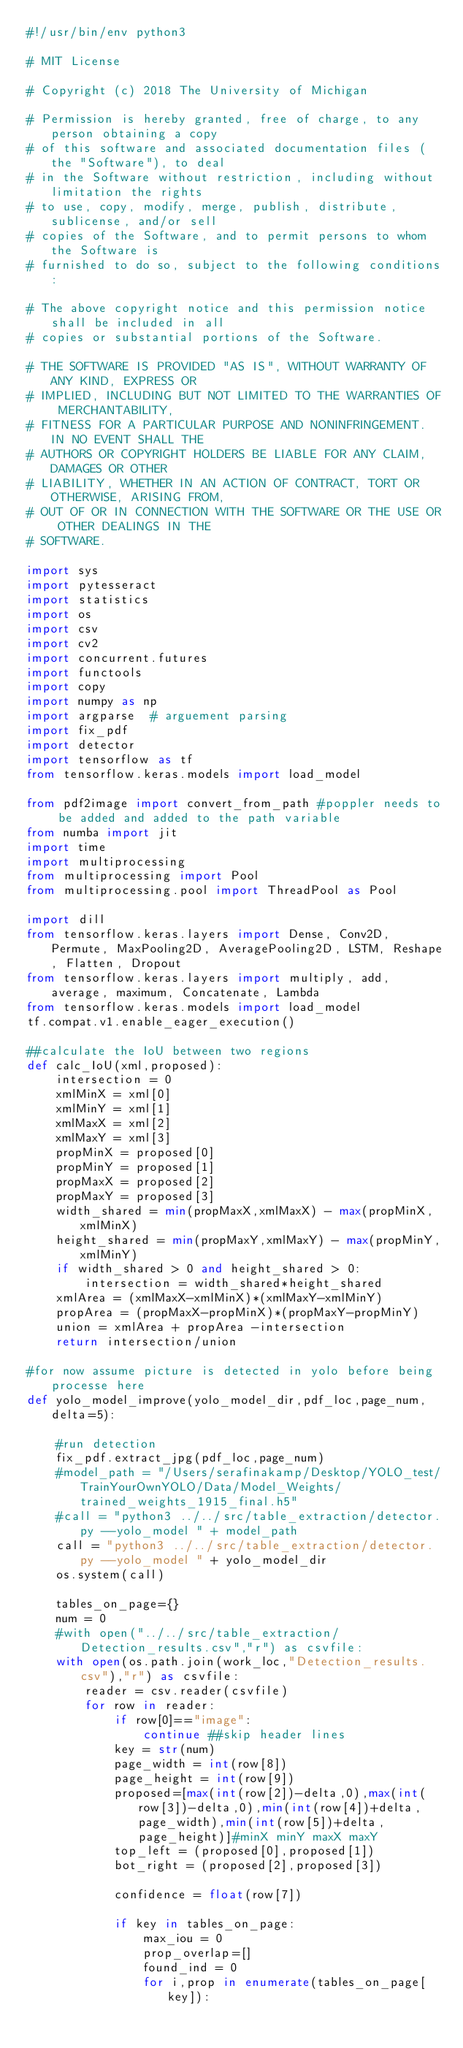Convert code to text. <code><loc_0><loc_0><loc_500><loc_500><_Python_>#!/usr/bin/env python3

# MIT License

# Copyright (c) 2018 The University of Michigan

# Permission is hereby granted, free of charge, to any person obtaining a copy
# of this software and associated documentation files (the "Software"), to deal
# in the Software without restriction, including without limitation the rights
# to use, copy, modify, merge, publish, distribute, sublicense, and/or sell
# copies of the Software, and to permit persons to whom the Software is
# furnished to do so, subject to the following conditions:

# The above copyright notice and this permission notice shall be included in all
# copies or substantial portions of the Software.

# THE SOFTWARE IS PROVIDED "AS IS", WITHOUT WARRANTY OF ANY KIND, EXPRESS OR
# IMPLIED, INCLUDING BUT NOT LIMITED TO THE WARRANTIES OF MERCHANTABILITY,
# FITNESS FOR A PARTICULAR PURPOSE AND NONINFRINGEMENT. IN NO EVENT SHALL THE
# AUTHORS OR COPYRIGHT HOLDERS BE LIABLE FOR ANY CLAIM, DAMAGES OR OTHER
# LIABILITY, WHETHER IN AN ACTION OF CONTRACT, TORT OR OTHERWISE, ARISING FROM,
# OUT OF OR IN CONNECTION WITH THE SOFTWARE OR THE USE OR OTHER DEALINGS IN THE
# SOFTWARE.

import sys
import pytesseract
import statistics
import os
import csv
import cv2
import concurrent.futures
import functools
import copy
import numpy as np
import argparse  # arguement parsing
import fix_pdf
import detector
import tensorflow as tf
from tensorflow.keras.models import load_model

from pdf2image import convert_from_path #poppler needs to be added and added to the path variable
from numba import jit
import time
import multiprocessing
from multiprocessing import Pool
from multiprocessing.pool import ThreadPool as Pool

import dill
from tensorflow.keras.layers import Dense, Conv2D, Permute, MaxPooling2D, AveragePooling2D, LSTM, Reshape, Flatten, Dropout
from tensorflow.keras.layers import multiply, add, average, maximum, Concatenate, Lambda
from tensorflow.keras.models import load_model
tf.compat.v1.enable_eager_execution()

##calculate the IoU between two regions
def calc_IoU(xml,proposed):
    intersection = 0
    xmlMinX = xml[0]
    xmlMinY = xml[1]
    xmlMaxX = xml[2]
    xmlMaxY = xml[3]
    propMinX = proposed[0]
    propMinY = proposed[1]
    propMaxX = proposed[2]
    propMaxY = proposed[3]
    width_shared = min(propMaxX,xmlMaxX) - max(propMinX,xmlMinX)
    height_shared = min(propMaxY,xmlMaxY) - max(propMinY,xmlMinY)
    if width_shared > 0 and height_shared > 0:
        intersection = width_shared*height_shared
    xmlArea = (xmlMaxX-xmlMinX)*(xmlMaxY-xmlMinY)
    propArea = (propMaxX-propMinX)*(propMaxY-propMinY)
    union = xmlArea + propArea -intersection
    return intersection/union

#for now assume picture is detected in yolo before being processe here
def yolo_model_improve(yolo_model_dir,pdf_loc,page_num,delta=5):

    #run detection
    fix_pdf.extract_jpg(pdf_loc,page_num)
    #model_path = "/Users/serafinakamp/Desktop/YOLO_test/TrainYourOwnYOLO/Data/Model_Weights/trained_weights_1915_final.h5"
    #call = "python3 ../../src/table_extraction/detector.py --yolo_model " + model_path
    call = "python3 ../../src/table_extraction/detector.py --yolo_model " + yolo_model_dir
    os.system(call)

    tables_on_page={}
    num = 0
    #with open("../../src/table_extraction/Detection_results.csv","r") as csvfile:
    with open(os.path.join(work_loc,"Detection_results.csv"),"r") as csvfile:
        reader = csv.reader(csvfile)
        for row in reader:
            if row[0]=="image":
                continue ##skip header lines
            key = str(num)
            page_width = int(row[8])
            page_height = int(row[9])
            proposed=[max(int(row[2])-delta,0),max(int(row[3])-delta,0),min(int(row[4])+delta,page_width),min(int(row[5])+delta,page_height)]#minX minY maxX maxY
            top_left = (proposed[0],proposed[1])
            bot_right = (proposed[2],proposed[3])

            confidence = float(row[7])

            if key in tables_on_page:
                max_iou = 0
                prop_overlap=[]
                found_ind = 0
                for i,prop in enumerate(tables_on_page[key]):
</code> 